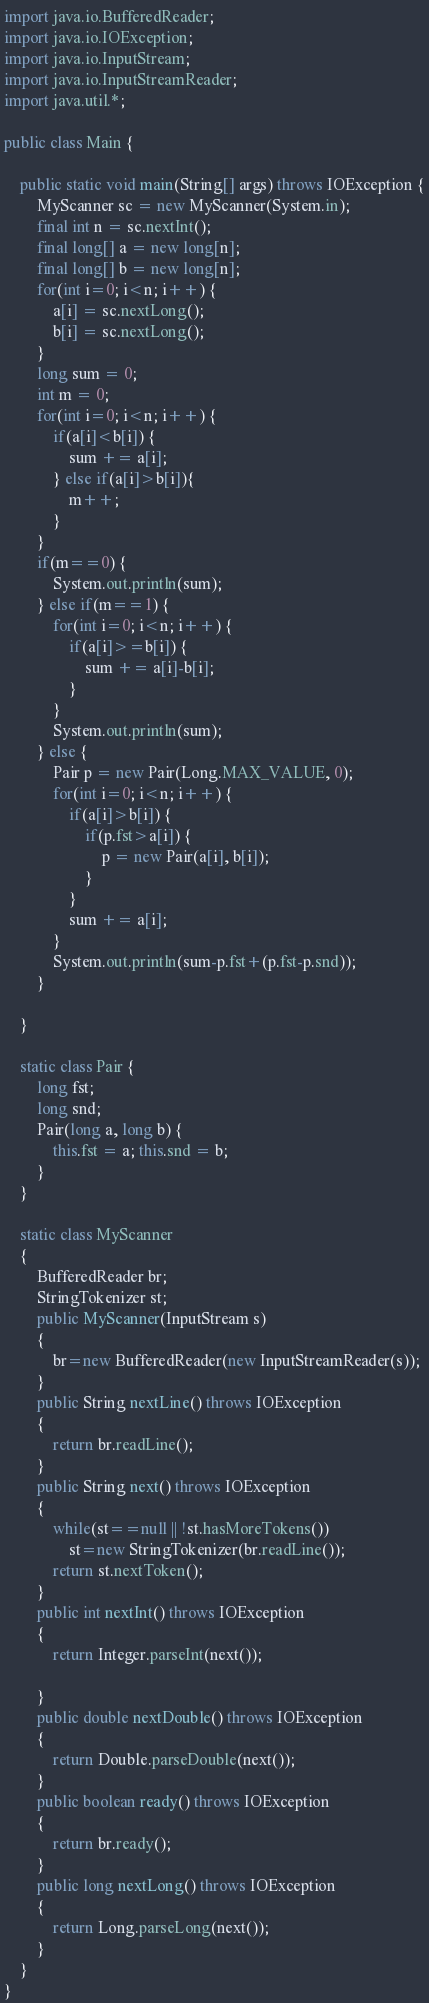<code> <loc_0><loc_0><loc_500><loc_500><_Java_>import java.io.BufferedReader;
import java.io.IOException;
import java.io.InputStream;
import java.io.InputStreamReader;
import java.util.*;

public class Main {

	public static void main(String[] args) throws IOException {
		MyScanner sc = new MyScanner(System.in);
		final int n = sc.nextInt();
		final long[] a = new long[n];
		final long[] b = new long[n];
		for(int i=0; i<n; i++) {
			a[i] = sc.nextLong();
			b[i] = sc.nextLong();
		}
		long sum = 0;
		int m = 0;
		for(int i=0; i<n; i++) {
			if(a[i]<b[i]) {
				sum += a[i];
			} else if(a[i]>b[i]){
				m++;
			}
		}
		if(m==0) {
			System.out.println(sum);
		} else if(m==1) {
			for(int i=0; i<n; i++) {
				if(a[i]>=b[i]) {
					sum += a[i]-b[i];
				}
			}
			System.out.println(sum);
		} else {
			Pair p = new Pair(Long.MAX_VALUE, 0);
			for(int i=0; i<n; i++) {
				if(a[i]>b[i]) {
					if(p.fst>a[i]) {
						p = new Pair(a[i], b[i]);
					}
				}
				sum += a[i];
			}
			System.out.println(sum-p.fst+(p.fst-p.snd));
		}

	}
	
	static class Pair {
		long fst;
		long snd;
		Pair(long a, long b) {
			this.fst = a; this.snd = b;
		}
	}

	static class MyScanner
	{
		BufferedReader br;
		StringTokenizer st;
		public MyScanner(InputStream s)
		{
			br=new BufferedReader(new InputStreamReader(s));
		}
		public String nextLine() throws IOException
		{
			return br.readLine();
		}
		public String next() throws IOException
		{
			while(st==null || !st.hasMoreTokens())
				st=new StringTokenizer(br.readLine());
			return st.nextToken();
		}
		public int nextInt() throws IOException
		{
			return Integer.parseInt(next());
			
		}
		public double nextDouble() throws IOException
		{
			return Double.parseDouble(next());
		}
		public boolean ready() throws IOException
		{
			return br.ready();
		}
		public long nextLong() throws IOException
		{
			return Long.parseLong(next());
		}
	}
}
</code> 